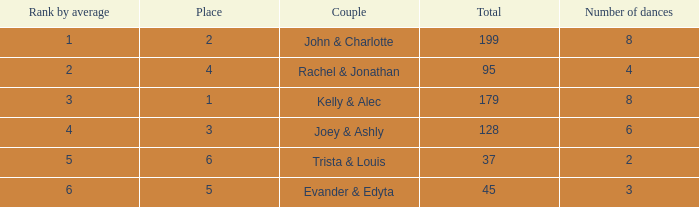What is the top average for 6 dances with an overall total above 128? None. 